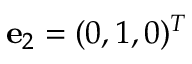<formula> <loc_0><loc_0><loc_500><loc_500>{ e } _ { 2 } = ( 0 , 1 , 0 ) ^ { T }</formula> 